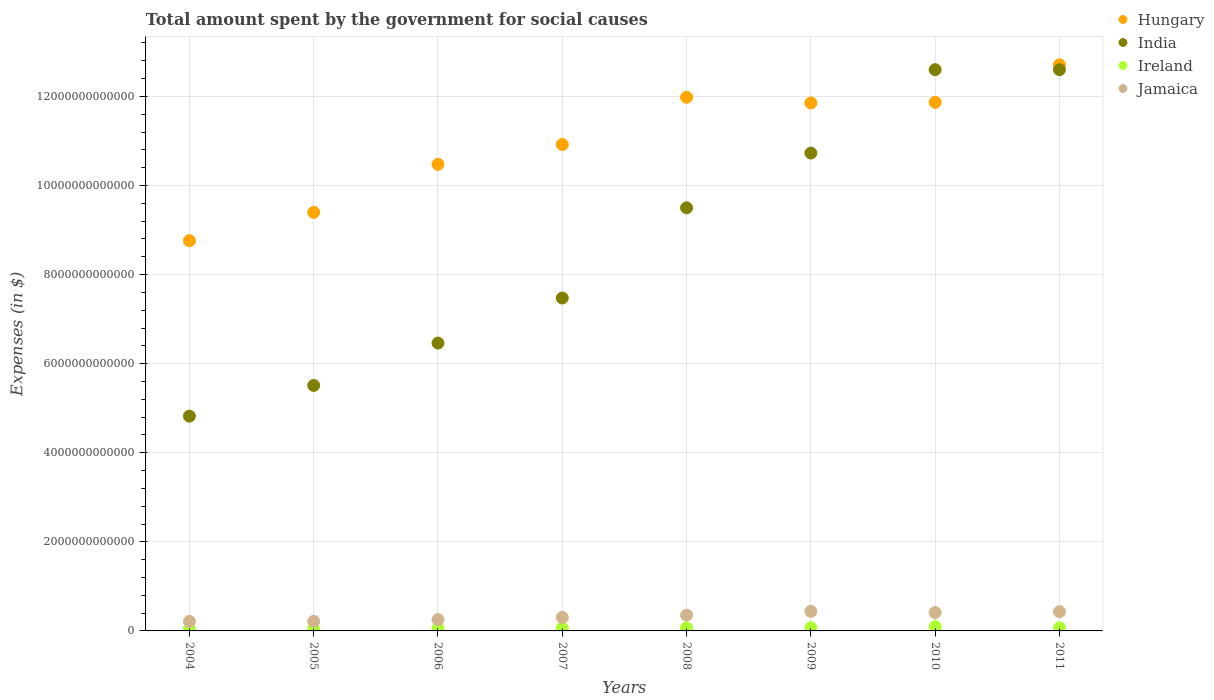What is the amount spent for social causes by the government in Ireland in 2004?
Your answer should be very brief. 4.48e+1. Across all years, what is the maximum amount spent for social causes by the government in Hungary?
Make the answer very short. 1.27e+13. Across all years, what is the minimum amount spent for social causes by the government in Hungary?
Provide a succinct answer. 8.76e+12. What is the total amount spent for social causes by the government in Hungary in the graph?
Your response must be concise. 8.80e+13. What is the difference between the amount spent for social causes by the government in India in 2005 and that in 2009?
Provide a succinct answer. -5.22e+12. What is the difference between the amount spent for social causes by the government in Ireland in 2004 and the amount spent for social causes by the government in India in 2008?
Provide a succinct answer. -9.45e+12. What is the average amount spent for social causes by the government in Jamaica per year?
Your response must be concise. 3.28e+11. In the year 2005, what is the difference between the amount spent for social causes by the government in Hungary and amount spent for social causes by the government in India?
Offer a very short reply. 3.89e+12. In how many years, is the amount spent for social causes by the government in Jamaica greater than 2000000000000 $?
Make the answer very short. 0. What is the ratio of the amount spent for social causes by the government in Jamaica in 2007 to that in 2008?
Make the answer very short. 0.85. Is the amount spent for social causes by the government in India in 2007 less than that in 2011?
Offer a very short reply. Yes. Is the difference between the amount spent for social causes by the government in Hungary in 2006 and 2010 greater than the difference between the amount spent for social causes by the government in India in 2006 and 2010?
Provide a short and direct response. Yes. What is the difference between the highest and the second highest amount spent for social causes by the government in Hungary?
Offer a terse response. 7.30e+11. What is the difference between the highest and the lowest amount spent for social causes by the government in Ireland?
Ensure brevity in your answer.  5.34e+1. Is the sum of the amount spent for social causes by the government in Ireland in 2007 and 2009 greater than the maximum amount spent for social causes by the government in Jamaica across all years?
Offer a very short reply. No. Is it the case that in every year, the sum of the amount spent for social causes by the government in India and amount spent for social causes by the government in Ireland  is greater than the sum of amount spent for social causes by the government in Hungary and amount spent for social causes by the government in Jamaica?
Provide a succinct answer. No. Is it the case that in every year, the sum of the amount spent for social causes by the government in Ireland and amount spent for social causes by the government in Jamaica  is greater than the amount spent for social causes by the government in Hungary?
Give a very brief answer. No. How many dotlines are there?
Give a very brief answer. 4. How many years are there in the graph?
Your answer should be very brief. 8. What is the difference between two consecutive major ticks on the Y-axis?
Make the answer very short. 2.00e+12. Are the values on the major ticks of Y-axis written in scientific E-notation?
Offer a very short reply. No. Does the graph contain any zero values?
Your answer should be compact. No. Where does the legend appear in the graph?
Make the answer very short. Top right. How many legend labels are there?
Offer a terse response. 4. What is the title of the graph?
Give a very brief answer. Total amount spent by the government for social causes. What is the label or title of the Y-axis?
Ensure brevity in your answer.  Expenses (in $). What is the Expenses (in $) of Hungary in 2004?
Offer a terse response. 8.76e+12. What is the Expenses (in $) in India in 2004?
Provide a succinct answer. 4.82e+12. What is the Expenses (in $) of Ireland in 2004?
Provide a short and direct response. 4.48e+1. What is the Expenses (in $) of Jamaica in 2004?
Offer a very short reply. 2.14e+11. What is the Expenses (in $) of Hungary in 2005?
Keep it short and to the point. 9.40e+12. What is the Expenses (in $) of India in 2005?
Provide a short and direct response. 5.51e+12. What is the Expenses (in $) of Ireland in 2005?
Ensure brevity in your answer.  5.01e+1. What is the Expenses (in $) of Jamaica in 2005?
Provide a short and direct response. 2.15e+11. What is the Expenses (in $) of Hungary in 2006?
Your response must be concise. 1.05e+13. What is the Expenses (in $) of India in 2006?
Your answer should be very brief. 6.46e+12. What is the Expenses (in $) of Ireland in 2006?
Provide a succinct answer. 5.51e+1. What is the Expenses (in $) in Jamaica in 2006?
Your response must be concise. 2.55e+11. What is the Expenses (in $) of Hungary in 2007?
Your response must be concise. 1.09e+13. What is the Expenses (in $) of India in 2007?
Give a very brief answer. 7.47e+12. What is the Expenses (in $) of Ireland in 2007?
Keep it short and to the point. 6.16e+1. What is the Expenses (in $) of Jamaica in 2007?
Keep it short and to the point. 3.03e+11. What is the Expenses (in $) of Hungary in 2008?
Provide a short and direct response. 1.20e+13. What is the Expenses (in $) in India in 2008?
Provide a succinct answer. 9.50e+12. What is the Expenses (in $) of Ireland in 2008?
Keep it short and to the point. 6.77e+1. What is the Expenses (in $) in Jamaica in 2008?
Your response must be concise. 3.55e+11. What is the Expenses (in $) in Hungary in 2009?
Your response must be concise. 1.19e+13. What is the Expenses (in $) of India in 2009?
Your response must be concise. 1.07e+13. What is the Expenses (in $) of Ireland in 2009?
Offer a terse response. 7.27e+1. What is the Expenses (in $) in Jamaica in 2009?
Keep it short and to the point. 4.39e+11. What is the Expenses (in $) in Hungary in 2010?
Your answer should be compact. 1.19e+13. What is the Expenses (in $) of India in 2010?
Offer a very short reply. 1.26e+13. What is the Expenses (in $) in Ireland in 2010?
Ensure brevity in your answer.  9.83e+1. What is the Expenses (in $) in Jamaica in 2010?
Keep it short and to the point. 4.12e+11. What is the Expenses (in $) in Hungary in 2011?
Offer a terse response. 1.27e+13. What is the Expenses (in $) in India in 2011?
Keep it short and to the point. 1.26e+13. What is the Expenses (in $) of Ireland in 2011?
Provide a short and direct response. 7.14e+1. What is the Expenses (in $) in Jamaica in 2011?
Your response must be concise. 4.31e+11. Across all years, what is the maximum Expenses (in $) of Hungary?
Ensure brevity in your answer.  1.27e+13. Across all years, what is the maximum Expenses (in $) in India?
Your response must be concise. 1.26e+13. Across all years, what is the maximum Expenses (in $) in Ireland?
Provide a succinct answer. 9.83e+1. Across all years, what is the maximum Expenses (in $) of Jamaica?
Keep it short and to the point. 4.39e+11. Across all years, what is the minimum Expenses (in $) in Hungary?
Keep it short and to the point. 8.76e+12. Across all years, what is the minimum Expenses (in $) of India?
Make the answer very short. 4.82e+12. Across all years, what is the minimum Expenses (in $) in Ireland?
Ensure brevity in your answer.  4.48e+1. Across all years, what is the minimum Expenses (in $) of Jamaica?
Make the answer very short. 2.14e+11. What is the total Expenses (in $) of Hungary in the graph?
Keep it short and to the point. 8.80e+13. What is the total Expenses (in $) of India in the graph?
Your answer should be compact. 6.97e+13. What is the total Expenses (in $) in Ireland in the graph?
Provide a succinct answer. 5.22e+11. What is the total Expenses (in $) of Jamaica in the graph?
Ensure brevity in your answer.  2.63e+12. What is the difference between the Expenses (in $) of Hungary in 2004 and that in 2005?
Keep it short and to the point. -6.37e+11. What is the difference between the Expenses (in $) of India in 2004 and that in 2005?
Your response must be concise. -6.89e+11. What is the difference between the Expenses (in $) of Ireland in 2004 and that in 2005?
Ensure brevity in your answer.  -5.29e+09. What is the difference between the Expenses (in $) of Jamaica in 2004 and that in 2005?
Provide a succinct answer. -1.88e+09. What is the difference between the Expenses (in $) of Hungary in 2004 and that in 2006?
Provide a succinct answer. -1.71e+12. What is the difference between the Expenses (in $) of India in 2004 and that in 2006?
Give a very brief answer. -1.64e+12. What is the difference between the Expenses (in $) of Ireland in 2004 and that in 2006?
Keep it short and to the point. -1.03e+1. What is the difference between the Expenses (in $) of Jamaica in 2004 and that in 2006?
Give a very brief answer. -4.11e+1. What is the difference between the Expenses (in $) in Hungary in 2004 and that in 2007?
Make the answer very short. -2.16e+12. What is the difference between the Expenses (in $) of India in 2004 and that in 2007?
Offer a very short reply. -2.65e+12. What is the difference between the Expenses (in $) of Ireland in 2004 and that in 2007?
Keep it short and to the point. -1.67e+1. What is the difference between the Expenses (in $) in Jamaica in 2004 and that in 2007?
Give a very brief answer. -8.98e+1. What is the difference between the Expenses (in $) in Hungary in 2004 and that in 2008?
Your answer should be compact. -3.22e+12. What is the difference between the Expenses (in $) of India in 2004 and that in 2008?
Offer a very short reply. -4.68e+12. What is the difference between the Expenses (in $) in Ireland in 2004 and that in 2008?
Offer a very short reply. -2.29e+1. What is the difference between the Expenses (in $) of Jamaica in 2004 and that in 2008?
Provide a succinct answer. -1.42e+11. What is the difference between the Expenses (in $) in Hungary in 2004 and that in 2009?
Offer a very short reply. -3.09e+12. What is the difference between the Expenses (in $) of India in 2004 and that in 2009?
Offer a terse response. -5.91e+12. What is the difference between the Expenses (in $) in Ireland in 2004 and that in 2009?
Ensure brevity in your answer.  -2.79e+1. What is the difference between the Expenses (in $) of Jamaica in 2004 and that in 2009?
Provide a short and direct response. -2.26e+11. What is the difference between the Expenses (in $) in Hungary in 2004 and that in 2010?
Give a very brief answer. -3.11e+12. What is the difference between the Expenses (in $) of India in 2004 and that in 2010?
Provide a succinct answer. -7.78e+12. What is the difference between the Expenses (in $) of Ireland in 2004 and that in 2010?
Your answer should be very brief. -5.34e+1. What is the difference between the Expenses (in $) of Jamaica in 2004 and that in 2010?
Ensure brevity in your answer.  -1.99e+11. What is the difference between the Expenses (in $) of Hungary in 2004 and that in 2011?
Offer a very short reply. -3.95e+12. What is the difference between the Expenses (in $) in India in 2004 and that in 2011?
Provide a succinct answer. -7.78e+12. What is the difference between the Expenses (in $) in Ireland in 2004 and that in 2011?
Your answer should be very brief. -2.66e+1. What is the difference between the Expenses (in $) in Jamaica in 2004 and that in 2011?
Offer a terse response. -2.18e+11. What is the difference between the Expenses (in $) in Hungary in 2005 and that in 2006?
Provide a short and direct response. -1.08e+12. What is the difference between the Expenses (in $) of India in 2005 and that in 2006?
Your response must be concise. -9.51e+11. What is the difference between the Expenses (in $) of Ireland in 2005 and that in 2006?
Offer a very short reply. -4.99e+09. What is the difference between the Expenses (in $) in Jamaica in 2005 and that in 2006?
Your answer should be very brief. -3.93e+1. What is the difference between the Expenses (in $) of Hungary in 2005 and that in 2007?
Make the answer very short. -1.52e+12. What is the difference between the Expenses (in $) of India in 2005 and that in 2007?
Provide a short and direct response. -1.96e+12. What is the difference between the Expenses (in $) in Ireland in 2005 and that in 2007?
Keep it short and to the point. -1.14e+1. What is the difference between the Expenses (in $) of Jamaica in 2005 and that in 2007?
Your answer should be compact. -8.79e+1. What is the difference between the Expenses (in $) in Hungary in 2005 and that in 2008?
Provide a short and direct response. -2.58e+12. What is the difference between the Expenses (in $) in India in 2005 and that in 2008?
Your response must be concise. -3.99e+12. What is the difference between the Expenses (in $) in Ireland in 2005 and that in 2008?
Offer a very short reply. -1.76e+1. What is the difference between the Expenses (in $) of Jamaica in 2005 and that in 2008?
Provide a short and direct response. -1.40e+11. What is the difference between the Expenses (in $) in Hungary in 2005 and that in 2009?
Give a very brief answer. -2.46e+12. What is the difference between the Expenses (in $) in India in 2005 and that in 2009?
Make the answer very short. -5.22e+12. What is the difference between the Expenses (in $) in Ireland in 2005 and that in 2009?
Your response must be concise. -2.26e+1. What is the difference between the Expenses (in $) of Jamaica in 2005 and that in 2009?
Provide a short and direct response. -2.24e+11. What is the difference between the Expenses (in $) of Hungary in 2005 and that in 2010?
Provide a succinct answer. -2.47e+12. What is the difference between the Expenses (in $) of India in 2005 and that in 2010?
Ensure brevity in your answer.  -7.09e+12. What is the difference between the Expenses (in $) in Ireland in 2005 and that in 2010?
Provide a succinct answer. -4.81e+1. What is the difference between the Expenses (in $) in Jamaica in 2005 and that in 2010?
Your answer should be compact. -1.97e+11. What is the difference between the Expenses (in $) in Hungary in 2005 and that in 2011?
Your answer should be very brief. -3.31e+12. What is the difference between the Expenses (in $) in India in 2005 and that in 2011?
Provide a succinct answer. -7.09e+12. What is the difference between the Expenses (in $) of Ireland in 2005 and that in 2011?
Give a very brief answer. -2.13e+1. What is the difference between the Expenses (in $) of Jamaica in 2005 and that in 2011?
Keep it short and to the point. -2.16e+11. What is the difference between the Expenses (in $) in Hungary in 2006 and that in 2007?
Keep it short and to the point. -4.47e+11. What is the difference between the Expenses (in $) in India in 2006 and that in 2007?
Provide a short and direct response. -1.01e+12. What is the difference between the Expenses (in $) in Ireland in 2006 and that in 2007?
Offer a very short reply. -6.45e+09. What is the difference between the Expenses (in $) of Jamaica in 2006 and that in 2007?
Keep it short and to the point. -4.86e+1. What is the difference between the Expenses (in $) in Hungary in 2006 and that in 2008?
Give a very brief answer. -1.51e+12. What is the difference between the Expenses (in $) in India in 2006 and that in 2008?
Offer a very short reply. -3.04e+12. What is the difference between the Expenses (in $) of Ireland in 2006 and that in 2008?
Your response must be concise. -1.26e+1. What is the difference between the Expenses (in $) in Jamaica in 2006 and that in 2008?
Give a very brief answer. -1.01e+11. What is the difference between the Expenses (in $) of Hungary in 2006 and that in 2009?
Provide a short and direct response. -1.38e+12. What is the difference between the Expenses (in $) in India in 2006 and that in 2009?
Provide a succinct answer. -4.27e+12. What is the difference between the Expenses (in $) in Ireland in 2006 and that in 2009?
Make the answer very short. -1.76e+1. What is the difference between the Expenses (in $) of Jamaica in 2006 and that in 2009?
Keep it short and to the point. -1.84e+11. What is the difference between the Expenses (in $) in Hungary in 2006 and that in 2010?
Give a very brief answer. -1.39e+12. What is the difference between the Expenses (in $) in India in 2006 and that in 2010?
Make the answer very short. -6.14e+12. What is the difference between the Expenses (in $) of Ireland in 2006 and that in 2010?
Offer a very short reply. -4.32e+1. What is the difference between the Expenses (in $) of Jamaica in 2006 and that in 2010?
Give a very brief answer. -1.58e+11. What is the difference between the Expenses (in $) in Hungary in 2006 and that in 2011?
Keep it short and to the point. -2.24e+12. What is the difference between the Expenses (in $) in India in 2006 and that in 2011?
Your answer should be very brief. -6.14e+12. What is the difference between the Expenses (in $) in Ireland in 2006 and that in 2011?
Provide a short and direct response. -1.63e+1. What is the difference between the Expenses (in $) of Jamaica in 2006 and that in 2011?
Keep it short and to the point. -1.77e+11. What is the difference between the Expenses (in $) in Hungary in 2007 and that in 2008?
Keep it short and to the point. -1.06e+12. What is the difference between the Expenses (in $) of India in 2007 and that in 2008?
Keep it short and to the point. -2.03e+12. What is the difference between the Expenses (in $) of Ireland in 2007 and that in 2008?
Keep it short and to the point. -6.16e+09. What is the difference between the Expenses (in $) in Jamaica in 2007 and that in 2008?
Your answer should be very brief. -5.21e+1. What is the difference between the Expenses (in $) in Hungary in 2007 and that in 2009?
Keep it short and to the point. -9.32e+11. What is the difference between the Expenses (in $) of India in 2007 and that in 2009?
Your answer should be compact. -3.25e+12. What is the difference between the Expenses (in $) of Ireland in 2007 and that in 2009?
Your response must be concise. -1.12e+1. What is the difference between the Expenses (in $) in Jamaica in 2007 and that in 2009?
Give a very brief answer. -1.36e+11. What is the difference between the Expenses (in $) in Hungary in 2007 and that in 2010?
Provide a short and direct response. -9.46e+11. What is the difference between the Expenses (in $) in India in 2007 and that in 2010?
Provide a succinct answer. -5.13e+12. What is the difference between the Expenses (in $) in Ireland in 2007 and that in 2010?
Provide a short and direct response. -3.67e+1. What is the difference between the Expenses (in $) in Jamaica in 2007 and that in 2010?
Offer a terse response. -1.09e+11. What is the difference between the Expenses (in $) in Hungary in 2007 and that in 2011?
Ensure brevity in your answer.  -1.79e+12. What is the difference between the Expenses (in $) in India in 2007 and that in 2011?
Provide a succinct answer. -5.13e+12. What is the difference between the Expenses (in $) in Ireland in 2007 and that in 2011?
Your answer should be compact. -9.88e+09. What is the difference between the Expenses (in $) of Jamaica in 2007 and that in 2011?
Make the answer very short. -1.28e+11. What is the difference between the Expenses (in $) in Hungary in 2008 and that in 2009?
Offer a terse response. 1.27e+11. What is the difference between the Expenses (in $) in India in 2008 and that in 2009?
Make the answer very short. -1.23e+12. What is the difference between the Expenses (in $) of Ireland in 2008 and that in 2009?
Give a very brief answer. -5.02e+09. What is the difference between the Expenses (in $) in Jamaica in 2008 and that in 2009?
Offer a very short reply. -8.36e+1. What is the difference between the Expenses (in $) in Hungary in 2008 and that in 2010?
Give a very brief answer. 1.13e+11. What is the difference between the Expenses (in $) of India in 2008 and that in 2010?
Offer a terse response. -3.10e+12. What is the difference between the Expenses (in $) in Ireland in 2008 and that in 2010?
Provide a short and direct response. -3.05e+1. What is the difference between the Expenses (in $) of Jamaica in 2008 and that in 2010?
Ensure brevity in your answer.  -5.69e+1. What is the difference between the Expenses (in $) in Hungary in 2008 and that in 2011?
Your answer should be very brief. -7.30e+11. What is the difference between the Expenses (in $) in India in 2008 and that in 2011?
Your answer should be very brief. -3.10e+12. What is the difference between the Expenses (in $) of Ireland in 2008 and that in 2011?
Provide a short and direct response. -3.72e+09. What is the difference between the Expenses (in $) in Jamaica in 2008 and that in 2011?
Make the answer very short. -7.60e+1. What is the difference between the Expenses (in $) of Hungary in 2009 and that in 2010?
Your answer should be compact. -1.46e+1. What is the difference between the Expenses (in $) of India in 2009 and that in 2010?
Give a very brief answer. -1.87e+12. What is the difference between the Expenses (in $) of Ireland in 2009 and that in 2010?
Make the answer very short. -2.55e+1. What is the difference between the Expenses (in $) of Jamaica in 2009 and that in 2010?
Keep it short and to the point. 2.67e+1. What is the difference between the Expenses (in $) of Hungary in 2009 and that in 2011?
Keep it short and to the point. -8.57e+11. What is the difference between the Expenses (in $) in India in 2009 and that in 2011?
Your response must be concise. -1.87e+12. What is the difference between the Expenses (in $) in Ireland in 2009 and that in 2011?
Make the answer very short. 1.31e+09. What is the difference between the Expenses (in $) in Jamaica in 2009 and that in 2011?
Ensure brevity in your answer.  7.65e+09. What is the difference between the Expenses (in $) in Hungary in 2010 and that in 2011?
Your answer should be compact. -8.42e+11. What is the difference between the Expenses (in $) in Ireland in 2010 and that in 2011?
Ensure brevity in your answer.  2.68e+1. What is the difference between the Expenses (in $) of Jamaica in 2010 and that in 2011?
Ensure brevity in your answer.  -1.90e+1. What is the difference between the Expenses (in $) in Hungary in 2004 and the Expenses (in $) in India in 2005?
Your response must be concise. 3.25e+12. What is the difference between the Expenses (in $) in Hungary in 2004 and the Expenses (in $) in Ireland in 2005?
Offer a terse response. 8.71e+12. What is the difference between the Expenses (in $) in Hungary in 2004 and the Expenses (in $) in Jamaica in 2005?
Offer a very short reply. 8.55e+12. What is the difference between the Expenses (in $) of India in 2004 and the Expenses (in $) of Ireland in 2005?
Offer a terse response. 4.77e+12. What is the difference between the Expenses (in $) of India in 2004 and the Expenses (in $) of Jamaica in 2005?
Make the answer very short. 4.61e+12. What is the difference between the Expenses (in $) of Ireland in 2004 and the Expenses (in $) of Jamaica in 2005?
Ensure brevity in your answer.  -1.71e+11. What is the difference between the Expenses (in $) of Hungary in 2004 and the Expenses (in $) of India in 2006?
Offer a terse response. 2.30e+12. What is the difference between the Expenses (in $) of Hungary in 2004 and the Expenses (in $) of Ireland in 2006?
Give a very brief answer. 8.71e+12. What is the difference between the Expenses (in $) of Hungary in 2004 and the Expenses (in $) of Jamaica in 2006?
Make the answer very short. 8.51e+12. What is the difference between the Expenses (in $) in India in 2004 and the Expenses (in $) in Ireland in 2006?
Your response must be concise. 4.77e+12. What is the difference between the Expenses (in $) in India in 2004 and the Expenses (in $) in Jamaica in 2006?
Offer a terse response. 4.57e+12. What is the difference between the Expenses (in $) of Ireland in 2004 and the Expenses (in $) of Jamaica in 2006?
Your answer should be compact. -2.10e+11. What is the difference between the Expenses (in $) of Hungary in 2004 and the Expenses (in $) of India in 2007?
Your answer should be very brief. 1.29e+12. What is the difference between the Expenses (in $) of Hungary in 2004 and the Expenses (in $) of Ireland in 2007?
Keep it short and to the point. 8.70e+12. What is the difference between the Expenses (in $) in Hungary in 2004 and the Expenses (in $) in Jamaica in 2007?
Your answer should be very brief. 8.46e+12. What is the difference between the Expenses (in $) of India in 2004 and the Expenses (in $) of Ireland in 2007?
Offer a very short reply. 4.76e+12. What is the difference between the Expenses (in $) in India in 2004 and the Expenses (in $) in Jamaica in 2007?
Keep it short and to the point. 4.52e+12. What is the difference between the Expenses (in $) in Ireland in 2004 and the Expenses (in $) in Jamaica in 2007?
Make the answer very short. -2.59e+11. What is the difference between the Expenses (in $) of Hungary in 2004 and the Expenses (in $) of India in 2008?
Your answer should be compact. -7.38e+11. What is the difference between the Expenses (in $) in Hungary in 2004 and the Expenses (in $) in Ireland in 2008?
Your answer should be very brief. 8.69e+12. What is the difference between the Expenses (in $) in Hungary in 2004 and the Expenses (in $) in Jamaica in 2008?
Provide a succinct answer. 8.41e+12. What is the difference between the Expenses (in $) of India in 2004 and the Expenses (in $) of Ireland in 2008?
Offer a very short reply. 4.75e+12. What is the difference between the Expenses (in $) in India in 2004 and the Expenses (in $) in Jamaica in 2008?
Your answer should be very brief. 4.47e+12. What is the difference between the Expenses (in $) of Ireland in 2004 and the Expenses (in $) of Jamaica in 2008?
Your response must be concise. -3.11e+11. What is the difference between the Expenses (in $) of Hungary in 2004 and the Expenses (in $) of India in 2009?
Provide a short and direct response. -1.97e+12. What is the difference between the Expenses (in $) of Hungary in 2004 and the Expenses (in $) of Ireland in 2009?
Your answer should be compact. 8.69e+12. What is the difference between the Expenses (in $) of Hungary in 2004 and the Expenses (in $) of Jamaica in 2009?
Provide a short and direct response. 8.32e+12. What is the difference between the Expenses (in $) in India in 2004 and the Expenses (in $) in Ireland in 2009?
Your answer should be very brief. 4.75e+12. What is the difference between the Expenses (in $) of India in 2004 and the Expenses (in $) of Jamaica in 2009?
Ensure brevity in your answer.  4.38e+12. What is the difference between the Expenses (in $) in Ireland in 2004 and the Expenses (in $) in Jamaica in 2009?
Provide a succinct answer. -3.94e+11. What is the difference between the Expenses (in $) of Hungary in 2004 and the Expenses (in $) of India in 2010?
Your answer should be compact. -3.84e+12. What is the difference between the Expenses (in $) of Hungary in 2004 and the Expenses (in $) of Ireland in 2010?
Offer a terse response. 8.66e+12. What is the difference between the Expenses (in $) in Hungary in 2004 and the Expenses (in $) in Jamaica in 2010?
Keep it short and to the point. 8.35e+12. What is the difference between the Expenses (in $) of India in 2004 and the Expenses (in $) of Ireland in 2010?
Provide a succinct answer. 4.72e+12. What is the difference between the Expenses (in $) of India in 2004 and the Expenses (in $) of Jamaica in 2010?
Keep it short and to the point. 4.41e+12. What is the difference between the Expenses (in $) in Ireland in 2004 and the Expenses (in $) in Jamaica in 2010?
Offer a terse response. -3.68e+11. What is the difference between the Expenses (in $) in Hungary in 2004 and the Expenses (in $) in India in 2011?
Make the answer very short. -3.84e+12. What is the difference between the Expenses (in $) of Hungary in 2004 and the Expenses (in $) of Ireland in 2011?
Your response must be concise. 8.69e+12. What is the difference between the Expenses (in $) in Hungary in 2004 and the Expenses (in $) in Jamaica in 2011?
Keep it short and to the point. 8.33e+12. What is the difference between the Expenses (in $) of India in 2004 and the Expenses (in $) of Ireland in 2011?
Your answer should be compact. 4.75e+12. What is the difference between the Expenses (in $) of India in 2004 and the Expenses (in $) of Jamaica in 2011?
Your answer should be compact. 4.39e+12. What is the difference between the Expenses (in $) of Ireland in 2004 and the Expenses (in $) of Jamaica in 2011?
Provide a succinct answer. -3.87e+11. What is the difference between the Expenses (in $) of Hungary in 2005 and the Expenses (in $) of India in 2006?
Ensure brevity in your answer.  2.94e+12. What is the difference between the Expenses (in $) in Hungary in 2005 and the Expenses (in $) in Ireland in 2006?
Provide a short and direct response. 9.34e+12. What is the difference between the Expenses (in $) in Hungary in 2005 and the Expenses (in $) in Jamaica in 2006?
Your answer should be compact. 9.14e+12. What is the difference between the Expenses (in $) of India in 2005 and the Expenses (in $) of Ireland in 2006?
Make the answer very short. 5.46e+12. What is the difference between the Expenses (in $) of India in 2005 and the Expenses (in $) of Jamaica in 2006?
Offer a very short reply. 5.26e+12. What is the difference between the Expenses (in $) of Ireland in 2005 and the Expenses (in $) of Jamaica in 2006?
Your answer should be compact. -2.05e+11. What is the difference between the Expenses (in $) of Hungary in 2005 and the Expenses (in $) of India in 2007?
Provide a short and direct response. 1.92e+12. What is the difference between the Expenses (in $) in Hungary in 2005 and the Expenses (in $) in Ireland in 2007?
Your answer should be very brief. 9.34e+12. What is the difference between the Expenses (in $) of Hungary in 2005 and the Expenses (in $) of Jamaica in 2007?
Offer a terse response. 9.09e+12. What is the difference between the Expenses (in $) of India in 2005 and the Expenses (in $) of Ireland in 2007?
Give a very brief answer. 5.45e+12. What is the difference between the Expenses (in $) of India in 2005 and the Expenses (in $) of Jamaica in 2007?
Your answer should be compact. 5.21e+12. What is the difference between the Expenses (in $) in Ireland in 2005 and the Expenses (in $) in Jamaica in 2007?
Make the answer very short. -2.53e+11. What is the difference between the Expenses (in $) in Hungary in 2005 and the Expenses (in $) in India in 2008?
Your answer should be very brief. -1.02e+11. What is the difference between the Expenses (in $) of Hungary in 2005 and the Expenses (in $) of Ireland in 2008?
Your response must be concise. 9.33e+12. What is the difference between the Expenses (in $) of Hungary in 2005 and the Expenses (in $) of Jamaica in 2008?
Provide a short and direct response. 9.04e+12. What is the difference between the Expenses (in $) in India in 2005 and the Expenses (in $) in Ireland in 2008?
Your response must be concise. 5.44e+12. What is the difference between the Expenses (in $) in India in 2005 and the Expenses (in $) in Jamaica in 2008?
Your response must be concise. 5.16e+12. What is the difference between the Expenses (in $) in Ireland in 2005 and the Expenses (in $) in Jamaica in 2008?
Provide a short and direct response. -3.05e+11. What is the difference between the Expenses (in $) in Hungary in 2005 and the Expenses (in $) in India in 2009?
Your answer should be very brief. -1.33e+12. What is the difference between the Expenses (in $) in Hungary in 2005 and the Expenses (in $) in Ireland in 2009?
Provide a succinct answer. 9.33e+12. What is the difference between the Expenses (in $) in Hungary in 2005 and the Expenses (in $) in Jamaica in 2009?
Provide a succinct answer. 8.96e+12. What is the difference between the Expenses (in $) in India in 2005 and the Expenses (in $) in Ireland in 2009?
Your answer should be compact. 5.44e+12. What is the difference between the Expenses (in $) in India in 2005 and the Expenses (in $) in Jamaica in 2009?
Your response must be concise. 5.07e+12. What is the difference between the Expenses (in $) of Ireland in 2005 and the Expenses (in $) of Jamaica in 2009?
Provide a short and direct response. -3.89e+11. What is the difference between the Expenses (in $) in Hungary in 2005 and the Expenses (in $) in India in 2010?
Provide a short and direct response. -3.20e+12. What is the difference between the Expenses (in $) of Hungary in 2005 and the Expenses (in $) of Ireland in 2010?
Offer a terse response. 9.30e+12. What is the difference between the Expenses (in $) in Hungary in 2005 and the Expenses (in $) in Jamaica in 2010?
Provide a short and direct response. 8.99e+12. What is the difference between the Expenses (in $) of India in 2005 and the Expenses (in $) of Ireland in 2010?
Provide a short and direct response. 5.41e+12. What is the difference between the Expenses (in $) in India in 2005 and the Expenses (in $) in Jamaica in 2010?
Ensure brevity in your answer.  5.10e+12. What is the difference between the Expenses (in $) of Ireland in 2005 and the Expenses (in $) of Jamaica in 2010?
Provide a short and direct response. -3.62e+11. What is the difference between the Expenses (in $) of Hungary in 2005 and the Expenses (in $) of India in 2011?
Offer a very short reply. -3.20e+12. What is the difference between the Expenses (in $) of Hungary in 2005 and the Expenses (in $) of Ireland in 2011?
Ensure brevity in your answer.  9.33e+12. What is the difference between the Expenses (in $) of Hungary in 2005 and the Expenses (in $) of Jamaica in 2011?
Offer a terse response. 8.97e+12. What is the difference between the Expenses (in $) in India in 2005 and the Expenses (in $) in Ireland in 2011?
Provide a succinct answer. 5.44e+12. What is the difference between the Expenses (in $) of India in 2005 and the Expenses (in $) of Jamaica in 2011?
Ensure brevity in your answer.  5.08e+12. What is the difference between the Expenses (in $) of Ireland in 2005 and the Expenses (in $) of Jamaica in 2011?
Make the answer very short. -3.81e+11. What is the difference between the Expenses (in $) of Hungary in 2006 and the Expenses (in $) of India in 2007?
Ensure brevity in your answer.  3.00e+12. What is the difference between the Expenses (in $) of Hungary in 2006 and the Expenses (in $) of Ireland in 2007?
Make the answer very short. 1.04e+13. What is the difference between the Expenses (in $) in Hungary in 2006 and the Expenses (in $) in Jamaica in 2007?
Provide a short and direct response. 1.02e+13. What is the difference between the Expenses (in $) in India in 2006 and the Expenses (in $) in Ireland in 2007?
Your answer should be very brief. 6.40e+12. What is the difference between the Expenses (in $) of India in 2006 and the Expenses (in $) of Jamaica in 2007?
Provide a succinct answer. 6.16e+12. What is the difference between the Expenses (in $) of Ireland in 2006 and the Expenses (in $) of Jamaica in 2007?
Provide a succinct answer. -2.48e+11. What is the difference between the Expenses (in $) of Hungary in 2006 and the Expenses (in $) of India in 2008?
Provide a short and direct response. 9.75e+11. What is the difference between the Expenses (in $) in Hungary in 2006 and the Expenses (in $) in Ireland in 2008?
Your answer should be very brief. 1.04e+13. What is the difference between the Expenses (in $) of Hungary in 2006 and the Expenses (in $) of Jamaica in 2008?
Provide a short and direct response. 1.01e+13. What is the difference between the Expenses (in $) in India in 2006 and the Expenses (in $) in Ireland in 2008?
Give a very brief answer. 6.39e+12. What is the difference between the Expenses (in $) in India in 2006 and the Expenses (in $) in Jamaica in 2008?
Your response must be concise. 6.11e+12. What is the difference between the Expenses (in $) in Ireland in 2006 and the Expenses (in $) in Jamaica in 2008?
Ensure brevity in your answer.  -3.00e+11. What is the difference between the Expenses (in $) of Hungary in 2006 and the Expenses (in $) of India in 2009?
Offer a terse response. -2.54e+11. What is the difference between the Expenses (in $) of Hungary in 2006 and the Expenses (in $) of Ireland in 2009?
Keep it short and to the point. 1.04e+13. What is the difference between the Expenses (in $) in Hungary in 2006 and the Expenses (in $) in Jamaica in 2009?
Make the answer very short. 1.00e+13. What is the difference between the Expenses (in $) of India in 2006 and the Expenses (in $) of Ireland in 2009?
Offer a very short reply. 6.39e+12. What is the difference between the Expenses (in $) of India in 2006 and the Expenses (in $) of Jamaica in 2009?
Your answer should be compact. 6.02e+12. What is the difference between the Expenses (in $) of Ireland in 2006 and the Expenses (in $) of Jamaica in 2009?
Your answer should be very brief. -3.84e+11. What is the difference between the Expenses (in $) of Hungary in 2006 and the Expenses (in $) of India in 2010?
Give a very brief answer. -2.13e+12. What is the difference between the Expenses (in $) in Hungary in 2006 and the Expenses (in $) in Ireland in 2010?
Your answer should be compact. 1.04e+13. What is the difference between the Expenses (in $) in Hungary in 2006 and the Expenses (in $) in Jamaica in 2010?
Your answer should be very brief. 1.01e+13. What is the difference between the Expenses (in $) in India in 2006 and the Expenses (in $) in Ireland in 2010?
Offer a terse response. 6.36e+12. What is the difference between the Expenses (in $) of India in 2006 and the Expenses (in $) of Jamaica in 2010?
Provide a succinct answer. 6.05e+12. What is the difference between the Expenses (in $) of Ireland in 2006 and the Expenses (in $) of Jamaica in 2010?
Your answer should be very brief. -3.57e+11. What is the difference between the Expenses (in $) of Hungary in 2006 and the Expenses (in $) of India in 2011?
Offer a very short reply. -2.13e+12. What is the difference between the Expenses (in $) in Hungary in 2006 and the Expenses (in $) in Ireland in 2011?
Make the answer very short. 1.04e+13. What is the difference between the Expenses (in $) in Hungary in 2006 and the Expenses (in $) in Jamaica in 2011?
Give a very brief answer. 1.00e+13. What is the difference between the Expenses (in $) in India in 2006 and the Expenses (in $) in Ireland in 2011?
Offer a very short reply. 6.39e+12. What is the difference between the Expenses (in $) of India in 2006 and the Expenses (in $) of Jamaica in 2011?
Offer a terse response. 6.03e+12. What is the difference between the Expenses (in $) in Ireland in 2006 and the Expenses (in $) in Jamaica in 2011?
Your answer should be very brief. -3.76e+11. What is the difference between the Expenses (in $) of Hungary in 2007 and the Expenses (in $) of India in 2008?
Your answer should be compact. 1.42e+12. What is the difference between the Expenses (in $) in Hungary in 2007 and the Expenses (in $) in Ireland in 2008?
Make the answer very short. 1.09e+13. What is the difference between the Expenses (in $) of Hungary in 2007 and the Expenses (in $) of Jamaica in 2008?
Give a very brief answer. 1.06e+13. What is the difference between the Expenses (in $) of India in 2007 and the Expenses (in $) of Ireland in 2008?
Provide a short and direct response. 7.41e+12. What is the difference between the Expenses (in $) in India in 2007 and the Expenses (in $) in Jamaica in 2008?
Make the answer very short. 7.12e+12. What is the difference between the Expenses (in $) in Ireland in 2007 and the Expenses (in $) in Jamaica in 2008?
Provide a succinct answer. -2.94e+11. What is the difference between the Expenses (in $) in Hungary in 2007 and the Expenses (in $) in India in 2009?
Make the answer very short. 1.93e+11. What is the difference between the Expenses (in $) of Hungary in 2007 and the Expenses (in $) of Ireland in 2009?
Your answer should be very brief. 1.08e+13. What is the difference between the Expenses (in $) in Hungary in 2007 and the Expenses (in $) in Jamaica in 2009?
Make the answer very short. 1.05e+13. What is the difference between the Expenses (in $) of India in 2007 and the Expenses (in $) of Ireland in 2009?
Give a very brief answer. 7.40e+12. What is the difference between the Expenses (in $) in India in 2007 and the Expenses (in $) in Jamaica in 2009?
Give a very brief answer. 7.04e+12. What is the difference between the Expenses (in $) in Ireland in 2007 and the Expenses (in $) in Jamaica in 2009?
Your answer should be compact. -3.78e+11. What is the difference between the Expenses (in $) of Hungary in 2007 and the Expenses (in $) of India in 2010?
Ensure brevity in your answer.  -1.68e+12. What is the difference between the Expenses (in $) of Hungary in 2007 and the Expenses (in $) of Ireland in 2010?
Keep it short and to the point. 1.08e+13. What is the difference between the Expenses (in $) in Hungary in 2007 and the Expenses (in $) in Jamaica in 2010?
Your answer should be compact. 1.05e+13. What is the difference between the Expenses (in $) of India in 2007 and the Expenses (in $) of Ireland in 2010?
Offer a terse response. 7.38e+12. What is the difference between the Expenses (in $) of India in 2007 and the Expenses (in $) of Jamaica in 2010?
Offer a terse response. 7.06e+12. What is the difference between the Expenses (in $) of Ireland in 2007 and the Expenses (in $) of Jamaica in 2010?
Keep it short and to the point. -3.51e+11. What is the difference between the Expenses (in $) in Hungary in 2007 and the Expenses (in $) in India in 2011?
Keep it short and to the point. -1.68e+12. What is the difference between the Expenses (in $) of Hungary in 2007 and the Expenses (in $) of Ireland in 2011?
Your answer should be compact. 1.09e+13. What is the difference between the Expenses (in $) in Hungary in 2007 and the Expenses (in $) in Jamaica in 2011?
Your response must be concise. 1.05e+13. What is the difference between the Expenses (in $) of India in 2007 and the Expenses (in $) of Ireland in 2011?
Give a very brief answer. 7.40e+12. What is the difference between the Expenses (in $) in India in 2007 and the Expenses (in $) in Jamaica in 2011?
Ensure brevity in your answer.  7.04e+12. What is the difference between the Expenses (in $) in Ireland in 2007 and the Expenses (in $) in Jamaica in 2011?
Provide a succinct answer. -3.70e+11. What is the difference between the Expenses (in $) of Hungary in 2008 and the Expenses (in $) of India in 2009?
Provide a succinct answer. 1.25e+12. What is the difference between the Expenses (in $) of Hungary in 2008 and the Expenses (in $) of Ireland in 2009?
Your answer should be compact. 1.19e+13. What is the difference between the Expenses (in $) of Hungary in 2008 and the Expenses (in $) of Jamaica in 2009?
Provide a short and direct response. 1.15e+13. What is the difference between the Expenses (in $) of India in 2008 and the Expenses (in $) of Ireland in 2009?
Ensure brevity in your answer.  9.43e+12. What is the difference between the Expenses (in $) in India in 2008 and the Expenses (in $) in Jamaica in 2009?
Ensure brevity in your answer.  9.06e+12. What is the difference between the Expenses (in $) in Ireland in 2008 and the Expenses (in $) in Jamaica in 2009?
Provide a succinct answer. -3.71e+11. What is the difference between the Expenses (in $) of Hungary in 2008 and the Expenses (in $) of India in 2010?
Ensure brevity in your answer.  -6.20e+11. What is the difference between the Expenses (in $) in Hungary in 2008 and the Expenses (in $) in Ireland in 2010?
Ensure brevity in your answer.  1.19e+13. What is the difference between the Expenses (in $) of Hungary in 2008 and the Expenses (in $) of Jamaica in 2010?
Ensure brevity in your answer.  1.16e+13. What is the difference between the Expenses (in $) in India in 2008 and the Expenses (in $) in Ireland in 2010?
Make the answer very short. 9.40e+12. What is the difference between the Expenses (in $) in India in 2008 and the Expenses (in $) in Jamaica in 2010?
Provide a short and direct response. 9.09e+12. What is the difference between the Expenses (in $) of Ireland in 2008 and the Expenses (in $) of Jamaica in 2010?
Offer a very short reply. -3.45e+11. What is the difference between the Expenses (in $) of Hungary in 2008 and the Expenses (in $) of India in 2011?
Make the answer very short. -6.20e+11. What is the difference between the Expenses (in $) in Hungary in 2008 and the Expenses (in $) in Ireland in 2011?
Your answer should be compact. 1.19e+13. What is the difference between the Expenses (in $) in Hungary in 2008 and the Expenses (in $) in Jamaica in 2011?
Provide a short and direct response. 1.15e+13. What is the difference between the Expenses (in $) of India in 2008 and the Expenses (in $) of Ireland in 2011?
Make the answer very short. 9.43e+12. What is the difference between the Expenses (in $) of India in 2008 and the Expenses (in $) of Jamaica in 2011?
Provide a short and direct response. 9.07e+12. What is the difference between the Expenses (in $) of Ireland in 2008 and the Expenses (in $) of Jamaica in 2011?
Ensure brevity in your answer.  -3.64e+11. What is the difference between the Expenses (in $) in Hungary in 2009 and the Expenses (in $) in India in 2010?
Your answer should be compact. -7.47e+11. What is the difference between the Expenses (in $) of Hungary in 2009 and the Expenses (in $) of Ireland in 2010?
Your answer should be compact. 1.18e+13. What is the difference between the Expenses (in $) of Hungary in 2009 and the Expenses (in $) of Jamaica in 2010?
Offer a terse response. 1.14e+13. What is the difference between the Expenses (in $) of India in 2009 and the Expenses (in $) of Ireland in 2010?
Provide a succinct answer. 1.06e+13. What is the difference between the Expenses (in $) of India in 2009 and the Expenses (in $) of Jamaica in 2010?
Your response must be concise. 1.03e+13. What is the difference between the Expenses (in $) in Ireland in 2009 and the Expenses (in $) in Jamaica in 2010?
Ensure brevity in your answer.  -3.40e+11. What is the difference between the Expenses (in $) in Hungary in 2009 and the Expenses (in $) in India in 2011?
Keep it short and to the point. -7.47e+11. What is the difference between the Expenses (in $) of Hungary in 2009 and the Expenses (in $) of Ireland in 2011?
Keep it short and to the point. 1.18e+13. What is the difference between the Expenses (in $) of Hungary in 2009 and the Expenses (in $) of Jamaica in 2011?
Your answer should be compact. 1.14e+13. What is the difference between the Expenses (in $) in India in 2009 and the Expenses (in $) in Ireland in 2011?
Keep it short and to the point. 1.07e+13. What is the difference between the Expenses (in $) of India in 2009 and the Expenses (in $) of Jamaica in 2011?
Your answer should be very brief. 1.03e+13. What is the difference between the Expenses (in $) in Ireland in 2009 and the Expenses (in $) in Jamaica in 2011?
Offer a very short reply. -3.59e+11. What is the difference between the Expenses (in $) in Hungary in 2010 and the Expenses (in $) in India in 2011?
Give a very brief answer. -7.33e+11. What is the difference between the Expenses (in $) in Hungary in 2010 and the Expenses (in $) in Ireland in 2011?
Provide a short and direct response. 1.18e+13. What is the difference between the Expenses (in $) in Hungary in 2010 and the Expenses (in $) in Jamaica in 2011?
Provide a succinct answer. 1.14e+13. What is the difference between the Expenses (in $) of India in 2010 and the Expenses (in $) of Ireland in 2011?
Offer a very short reply. 1.25e+13. What is the difference between the Expenses (in $) in India in 2010 and the Expenses (in $) in Jamaica in 2011?
Keep it short and to the point. 1.22e+13. What is the difference between the Expenses (in $) of Ireland in 2010 and the Expenses (in $) of Jamaica in 2011?
Offer a very short reply. -3.33e+11. What is the average Expenses (in $) in Hungary per year?
Give a very brief answer. 1.10e+13. What is the average Expenses (in $) of India per year?
Your answer should be very brief. 8.71e+12. What is the average Expenses (in $) of Ireland per year?
Keep it short and to the point. 6.52e+1. What is the average Expenses (in $) in Jamaica per year?
Provide a succinct answer. 3.28e+11. In the year 2004, what is the difference between the Expenses (in $) in Hungary and Expenses (in $) in India?
Provide a succinct answer. 3.94e+12. In the year 2004, what is the difference between the Expenses (in $) of Hungary and Expenses (in $) of Ireland?
Make the answer very short. 8.72e+12. In the year 2004, what is the difference between the Expenses (in $) of Hungary and Expenses (in $) of Jamaica?
Make the answer very short. 8.55e+12. In the year 2004, what is the difference between the Expenses (in $) of India and Expenses (in $) of Ireland?
Offer a terse response. 4.78e+12. In the year 2004, what is the difference between the Expenses (in $) of India and Expenses (in $) of Jamaica?
Your response must be concise. 4.61e+12. In the year 2004, what is the difference between the Expenses (in $) in Ireland and Expenses (in $) in Jamaica?
Your answer should be compact. -1.69e+11. In the year 2005, what is the difference between the Expenses (in $) in Hungary and Expenses (in $) in India?
Offer a terse response. 3.89e+12. In the year 2005, what is the difference between the Expenses (in $) in Hungary and Expenses (in $) in Ireland?
Your response must be concise. 9.35e+12. In the year 2005, what is the difference between the Expenses (in $) of Hungary and Expenses (in $) of Jamaica?
Provide a short and direct response. 9.18e+12. In the year 2005, what is the difference between the Expenses (in $) in India and Expenses (in $) in Ireland?
Your answer should be very brief. 5.46e+12. In the year 2005, what is the difference between the Expenses (in $) in India and Expenses (in $) in Jamaica?
Provide a succinct answer. 5.30e+12. In the year 2005, what is the difference between the Expenses (in $) in Ireland and Expenses (in $) in Jamaica?
Your response must be concise. -1.65e+11. In the year 2006, what is the difference between the Expenses (in $) of Hungary and Expenses (in $) of India?
Ensure brevity in your answer.  4.01e+12. In the year 2006, what is the difference between the Expenses (in $) of Hungary and Expenses (in $) of Ireland?
Offer a very short reply. 1.04e+13. In the year 2006, what is the difference between the Expenses (in $) of Hungary and Expenses (in $) of Jamaica?
Keep it short and to the point. 1.02e+13. In the year 2006, what is the difference between the Expenses (in $) of India and Expenses (in $) of Ireland?
Provide a short and direct response. 6.41e+12. In the year 2006, what is the difference between the Expenses (in $) in India and Expenses (in $) in Jamaica?
Your answer should be very brief. 6.21e+12. In the year 2006, what is the difference between the Expenses (in $) in Ireland and Expenses (in $) in Jamaica?
Provide a short and direct response. -2.00e+11. In the year 2007, what is the difference between the Expenses (in $) in Hungary and Expenses (in $) in India?
Make the answer very short. 3.45e+12. In the year 2007, what is the difference between the Expenses (in $) in Hungary and Expenses (in $) in Ireland?
Offer a very short reply. 1.09e+13. In the year 2007, what is the difference between the Expenses (in $) of Hungary and Expenses (in $) of Jamaica?
Provide a short and direct response. 1.06e+13. In the year 2007, what is the difference between the Expenses (in $) of India and Expenses (in $) of Ireland?
Ensure brevity in your answer.  7.41e+12. In the year 2007, what is the difference between the Expenses (in $) in India and Expenses (in $) in Jamaica?
Your response must be concise. 7.17e+12. In the year 2007, what is the difference between the Expenses (in $) of Ireland and Expenses (in $) of Jamaica?
Provide a short and direct response. -2.42e+11. In the year 2008, what is the difference between the Expenses (in $) of Hungary and Expenses (in $) of India?
Provide a succinct answer. 2.48e+12. In the year 2008, what is the difference between the Expenses (in $) of Hungary and Expenses (in $) of Ireland?
Provide a succinct answer. 1.19e+13. In the year 2008, what is the difference between the Expenses (in $) of Hungary and Expenses (in $) of Jamaica?
Give a very brief answer. 1.16e+13. In the year 2008, what is the difference between the Expenses (in $) of India and Expenses (in $) of Ireland?
Give a very brief answer. 9.43e+12. In the year 2008, what is the difference between the Expenses (in $) in India and Expenses (in $) in Jamaica?
Ensure brevity in your answer.  9.14e+12. In the year 2008, what is the difference between the Expenses (in $) of Ireland and Expenses (in $) of Jamaica?
Your response must be concise. -2.88e+11. In the year 2009, what is the difference between the Expenses (in $) of Hungary and Expenses (in $) of India?
Your response must be concise. 1.13e+12. In the year 2009, what is the difference between the Expenses (in $) in Hungary and Expenses (in $) in Ireland?
Keep it short and to the point. 1.18e+13. In the year 2009, what is the difference between the Expenses (in $) in Hungary and Expenses (in $) in Jamaica?
Your answer should be very brief. 1.14e+13. In the year 2009, what is the difference between the Expenses (in $) of India and Expenses (in $) of Ireland?
Your answer should be compact. 1.07e+13. In the year 2009, what is the difference between the Expenses (in $) in India and Expenses (in $) in Jamaica?
Give a very brief answer. 1.03e+13. In the year 2009, what is the difference between the Expenses (in $) of Ireland and Expenses (in $) of Jamaica?
Your answer should be very brief. -3.66e+11. In the year 2010, what is the difference between the Expenses (in $) of Hungary and Expenses (in $) of India?
Your answer should be compact. -7.33e+11. In the year 2010, what is the difference between the Expenses (in $) of Hungary and Expenses (in $) of Ireland?
Keep it short and to the point. 1.18e+13. In the year 2010, what is the difference between the Expenses (in $) of Hungary and Expenses (in $) of Jamaica?
Your answer should be compact. 1.15e+13. In the year 2010, what is the difference between the Expenses (in $) in India and Expenses (in $) in Ireland?
Make the answer very short. 1.25e+13. In the year 2010, what is the difference between the Expenses (in $) of India and Expenses (in $) of Jamaica?
Provide a succinct answer. 1.22e+13. In the year 2010, what is the difference between the Expenses (in $) in Ireland and Expenses (in $) in Jamaica?
Keep it short and to the point. -3.14e+11. In the year 2011, what is the difference between the Expenses (in $) in Hungary and Expenses (in $) in India?
Keep it short and to the point. 1.10e+11. In the year 2011, what is the difference between the Expenses (in $) of Hungary and Expenses (in $) of Ireland?
Make the answer very short. 1.26e+13. In the year 2011, what is the difference between the Expenses (in $) in Hungary and Expenses (in $) in Jamaica?
Provide a short and direct response. 1.23e+13. In the year 2011, what is the difference between the Expenses (in $) in India and Expenses (in $) in Ireland?
Give a very brief answer. 1.25e+13. In the year 2011, what is the difference between the Expenses (in $) of India and Expenses (in $) of Jamaica?
Keep it short and to the point. 1.22e+13. In the year 2011, what is the difference between the Expenses (in $) in Ireland and Expenses (in $) in Jamaica?
Your response must be concise. -3.60e+11. What is the ratio of the Expenses (in $) in Hungary in 2004 to that in 2005?
Offer a terse response. 0.93. What is the ratio of the Expenses (in $) in India in 2004 to that in 2005?
Give a very brief answer. 0.87. What is the ratio of the Expenses (in $) of Ireland in 2004 to that in 2005?
Your answer should be very brief. 0.89. What is the ratio of the Expenses (in $) of Hungary in 2004 to that in 2006?
Give a very brief answer. 0.84. What is the ratio of the Expenses (in $) of India in 2004 to that in 2006?
Your answer should be very brief. 0.75. What is the ratio of the Expenses (in $) of Ireland in 2004 to that in 2006?
Make the answer very short. 0.81. What is the ratio of the Expenses (in $) of Jamaica in 2004 to that in 2006?
Give a very brief answer. 0.84. What is the ratio of the Expenses (in $) in Hungary in 2004 to that in 2007?
Provide a succinct answer. 0.8. What is the ratio of the Expenses (in $) of India in 2004 to that in 2007?
Provide a short and direct response. 0.65. What is the ratio of the Expenses (in $) in Ireland in 2004 to that in 2007?
Offer a terse response. 0.73. What is the ratio of the Expenses (in $) of Jamaica in 2004 to that in 2007?
Your answer should be very brief. 0.7. What is the ratio of the Expenses (in $) in Hungary in 2004 to that in 2008?
Offer a very short reply. 0.73. What is the ratio of the Expenses (in $) in India in 2004 to that in 2008?
Your answer should be compact. 0.51. What is the ratio of the Expenses (in $) in Ireland in 2004 to that in 2008?
Make the answer very short. 0.66. What is the ratio of the Expenses (in $) of Jamaica in 2004 to that in 2008?
Give a very brief answer. 0.6. What is the ratio of the Expenses (in $) in Hungary in 2004 to that in 2009?
Your response must be concise. 0.74. What is the ratio of the Expenses (in $) of India in 2004 to that in 2009?
Keep it short and to the point. 0.45. What is the ratio of the Expenses (in $) of Ireland in 2004 to that in 2009?
Provide a succinct answer. 0.62. What is the ratio of the Expenses (in $) in Jamaica in 2004 to that in 2009?
Your answer should be very brief. 0.49. What is the ratio of the Expenses (in $) in Hungary in 2004 to that in 2010?
Your answer should be compact. 0.74. What is the ratio of the Expenses (in $) of India in 2004 to that in 2010?
Your response must be concise. 0.38. What is the ratio of the Expenses (in $) of Ireland in 2004 to that in 2010?
Give a very brief answer. 0.46. What is the ratio of the Expenses (in $) of Jamaica in 2004 to that in 2010?
Provide a short and direct response. 0.52. What is the ratio of the Expenses (in $) of Hungary in 2004 to that in 2011?
Provide a short and direct response. 0.69. What is the ratio of the Expenses (in $) in India in 2004 to that in 2011?
Provide a short and direct response. 0.38. What is the ratio of the Expenses (in $) in Ireland in 2004 to that in 2011?
Your answer should be very brief. 0.63. What is the ratio of the Expenses (in $) of Jamaica in 2004 to that in 2011?
Offer a terse response. 0.49. What is the ratio of the Expenses (in $) in Hungary in 2005 to that in 2006?
Provide a succinct answer. 0.9. What is the ratio of the Expenses (in $) of India in 2005 to that in 2006?
Provide a succinct answer. 0.85. What is the ratio of the Expenses (in $) in Ireland in 2005 to that in 2006?
Your answer should be very brief. 0.91. What is the ratio of the Expenses (in $) in Jamaica in 2005 to that in 2006?
Provide a short and direct response. 0.85. What is the ratio of the Expenses (in $) in Hungary in 2005 to that in 2007?
Make the answer very short. 0.86. What is the ratio of the Expenses (in $) in India in 2005 to that in 2007?
Offer a terse response. 0.74. What is the ratio of the Expenses (in $) in Ireland in 2005 to that in 2007?
Your answer should be compact. 0.81. What is the ratio of the Expenses (in $) of Jamaica in 2005 to that in 2007?
Provide a succinct answer. 0.71. What is the ratio of the Expenses (in $) in Hungary in 2005 to that in 2008?
Offer a terse response. 0.78. What is the ratio of the Expenses (in $) in India in 2005 to that in 2008?
Provide a succinct answer. 0.58. What is the ratio of the Expenses (in $) in Ireland in 2005 to that in 2008?
Offer a terse response. 0.74. What is the ratio of the Expenses (in $) in Jamaica in 2005 to that in 2008?
Keep it short and to the point. 0.61. What is the ratio of the Expenses (in $) in Hungary in 2005 to that in 2009?
Your answer should be very brief. 0.79. What is the ratio of the Expenses (in $) in India in 2005 to that in 2009?
Make the answer very short. 0.51. What is the ratio of the Expenses (in $) of Ireland in 2005 to that in 2009?
Make the answer very short. 0.69. What is the ratio of the Expenses (in $) in Jamaica in 2005 to that in 2009?
Keep it short and to the point. 0.49. What is the ratio of the Expenses (in $) of Hungary in 2005 to that in 2010?
Your answer should be very brief. 0.79. What is the ratio of the Expenses (in $) of India in 2005 to that in 2010?
Keep it short and to the point. 0.44. What is the ratio of the Expenses (in $) of Ireland in 2005 to that in 2010?
Provide a succinct answer. 0.51. What is the ratio of the Expenses (in $) of Jamaica in 2005 to that in 2010?
Offer a terse response. 0.52. What is the ratio of the Expenses (in $) of Hungary in 2005 to that in 2011?
Keep it short and to the point. 0.74. What is the ratio of the Expenses (in $) of India in 2005 to that in 2011?
Your answer should be compact. 0.44. What is the ratio of the Expenses (in $) in Ireland in 2005 to that in 2011?
Give a very brief answer. 0.7. What is the ratio of the Expenses (in $) in Jamaica in 2005 to that in 2011?
Give a very brief answer. 0.5. What is the ratio of the Expenses (in $) of Hungary in 2006 to that in 2007?
Offer a very short reply. 0.96. What is the ratio of the Expenses (in $) of India in 2006 to that in 2007?
Offer a very short reply. 0.86. What is the ratio of the Expenses (in $) of Ireland in 2006 to that in 2007?
Provide a short and direct response. 0.9. What is the ratio of the Expenses (in $) in Jamaica in 2006 to that in 2007?
Keep it short and to the point. 0.84. What is the ratio of the Expenses (in $) in Hungary in 2006 to that in 2008?
Your answer should be compact. 0.87. What is the ratio of the Expenses (in $) in India in 2006 to that in 2008?
Your response must be concise. 0.68. What is the ratio of the Expenses (in $) in Ireland in 2006 to that in 2008?
Your response must be concise. 0.81. What is the ratio of the Expenses (in $) in Jamaica in 2006 to that in 2008?
Offer a terse response. 0.72. What is the ratio of the Expenses (in $) in Hungary in 2006 to that in 2009?
Your response must be concise. 0.88. What is the ratio of the Expenses (in $) of India in 2006 to that in 2009?
Make the answer very short. 0.6. What is the ratio of the Expenses (in $) of Ireland in 2006 to that in 2009?
Keep it short and to the point. 0.76. What is the ratio of the Expenses (in $) in Jamaica in 2006 to that in 2009?
Keep it short and to the point. 0.58. What is the ratio of the Expenses (in $) of Hungary in 2006 to that in 2010?
Your answer should be very brief. 0.88. What is the ratio of the Expenses (in $) of India in 2006 to that in 2010?
Make the answer very short. 0.51. What is the ratio of the Expenses (in $) of Ireland in 2006 to that in 2010?
Ensure brevity in your answer.  0.56. What is the ratio of the Expenses (in $) in Jamaica in 2006 to that in 2010?
Give a very brief answer. 0.62. What is the ratio of the Expenses (in $) of Hungary in 2006 to that in 2011?
Your answer should be very brief. 0.82. What is the ratio of the Expenses (in $) of India in 2006 to that in 2011?
Provide a succinct answer. 0.51. What is the ratio of the Expenses (in $) in Ireland in 2006 to that in 2011?
Ensure brevity in your answer.  0.77. What is the ratio of the Expenses (in $) in Jamaica in 2006 to that in 2011?
Your answer should be compact. 0.59. What is the ratio of the Expenses (in $) of Hungary in 2007 to that in 2008?
Offer a terse response. 0.91. What is the ratio of the Expenses (in $) of India in 2007 to that in 2008?
Keep it short and to the point. 0.79. What is the ratio of the Expenses (in $) in Ireland in 2007 to that in 2008?
Keep it short and to the point. 0.91. What is the ratio of the Expenses (in $) in Jamaica in 2007 to that in 2008?
Offer a very short reply. 0.85. What is the ratio of the Expenses (in $) of Hungary in 2007 to that in 2009?
Offer a terse response. 0.92. What is the ratio of the Expenses (in $) in India in 2007 to that in 2009?
Your answer should be very brief. 0.7. What is the ratio of the Expenses (in $) in Ireland in 2007 to that in 2009?
Keep it short and to the point. 0.85. What is the ratio of the Expenses (in $) of Jamaica in 2007 to that in 2009?
Offer a terse response. 0.69. What is the ratio of the Expenses (in $) of Hungary in 2007 to that in 2010?
Offer a terse response. 0.92. What is the ratio of the Expenses (in $) in India in 2007 to that in 2010?
Keep it short and to the point. 0.59. What is the ratio of the Expenses (in $) in Ireland in 2007 to that in 2010?
Your response must be concise. 0.63. What is the ratio of the Expenses (in $) of Jamaica in 2007 to that in 2010?
Give a very brief answer. 0.74. What is the ratio of the Expenses (in $) in Hungary in 2007 to that in 2011?
Give a very brief answer. 0.86. What is the ratio of the Expenses (in $) in India in 2007 to that in 2011?
Give a very brief answer. 0.59. What is the ratio of the Expenses (in $) in Ireland in 2007 to that in 2011?
Your answer should be compact. 0.86. What is the ratio of the Expenses (in $) in Jamaica in 2007 to that in 2011?
Your answer should be compact. 0.7. What is the ratio of the Expenses (in $) of Hungary in 2008 to that in 2009?
Make the answer very short. 1.01. What is the ratio of the Expenses (in $) in India in 2008 to that in 2009?
Your response must be concise. 0.89. What is the ratio of the Expenses (in $) in Ireland in 2008 to that in 2009?
Offer a terse response. 0.93. What is the ratio of the Expenses (in $) of Jamaica in 2008 to that in 2009?
Your response must be concise. 0.81. What is the ratio of the Expenses (in $) of Hungary in 2008 to that in 2010?
Offer a terse response. 1.01. What is the ratio of the Expenses (in $) of India in 2008 to that in 2010?
Offer a terse response. 0.75. What is the ratio of the Expenses (in $) of Ireland in 2008 to that in 2010?
Provide a short and direct response. 0.69. What is the ratio of the Expenses (in $) in Jamaica in 2008 to that in 2010?
Offer a very short reply. 0.86. What is the ratio of the Expenses (in $) in Hungary in 2008 to that in 2011?
Your answer should be compact. 0.94. What is the ratio of the Expenses (in $) of India in 2008 to that in 2011?
Give a very brief answer. 0.75. What is the ratio of the Expenses (in $) of Ireland in 2008 to that in 2011?
Your response must be concise. 0.95. What is the ratio of the Expenses (in $) in Jamaica in 2008 to that in 2011?
Give a very brief answer. 0.82. What is the ratio of the Expenses (in $) in Hungary in 2009 to that in 2010?
Make the answer very short. 1. What is the ratio of the Expenses (in $) in India in 2009 to that in 2010?
Provide a short and direct response. 0.85. What is the ratio of the Expenses (in $) of Ireland in 2009 to that in 2010?
Keep it short and to the point. 0.74. What is the ratio of the Expenses (in $) of Jamaica in 2009 to that in 2010?
Ensure brevity in your answer.  1.06. What is the ratio of the Expenses (in $) in Hungary in 2009 to that in 2011?
Your answer should be compact. 0.93. What is the ratio of the Expenses (in $) of India in 2009 to that in 2011?
Your answer should be compact. 0.85. What is the ratio of the Expenses (in $) in Ireland in 2009 to that in 2011?
Provide a short and direct response. 1.02. What is the ratio of the Expenses (in $) of Jamaica in 2009 to that in 2011?
Your answer should be very brief. 1.02. What is the ratio of the Expenses (in $) in Hungary in 2010 to that in 2011?
Keep it short and to the point. 0.93. What is the ratio of the Expenses (in $) of India in 2010 to that in 2011?
Keep it short and to the point. 1. What is the ratio of the Expenses (in $) of Ireland in 2010 to that in 2011?
Make the answer very short. 1.38. What is the ratio of the Expenses (in $) in Jamaica in 2010 to that in 2011?
Your answer should be very brief. 0.96. What is the difference between the highest and the second highest Expenses (in $) of Hungary?
Give a very brief answer. 7.30e+11. What is the difference between the highest and the second highest Expenses (in $) of Ireland?
Offer a very short reply. 2.55e+1. What is the difference between the highest and the second highest Expenses (in $) in Jamaica?
Your answer should be compact. 7.65e+09. What is the difference between the highest and the lowest Expenses (in $) in Hungary?
Your answer should be compact. 3.95e+12. What is the difference between the highest and the lowest Expenses (in $) in India?
Ensure brevity in your answer.  7.78e+12. What is the difference between the highest and the lowest Expenses (in $) in Ireland?
Your answer should be very brief. 5.34e+1. What is the difference between the highest and the lowest Expenses (in $) of Jamaica?
Provide a short and direct response. 2.26e+11. 